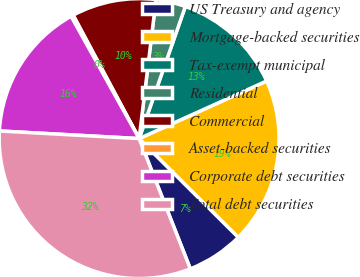Convert chart. <chart><loc_0><loc_0><loc_500><loc_500><pie_chart><fcel>US Treasury and agency<fcel>Mortgage-backed securities<fcel>Tax-exempt municipal<fcel>Residential<fcel>Commercial<fcel>Asset-backed securities<fcel>Corporate debt securities<fcel>Total debt securities<nl><fcel>6.58%<fcel>19.21%<fcel>12.89%<fcel>3.43%<fcel>9.74%<fcel>0.27%<fcel>16.05%<fcel>31.83%<nl></chart> 